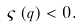Convert formula to latex. <formula><loc_0><loc_0><loc_500><loc_500>\varsigma \left ( q \right ) < 0 .</formula> 